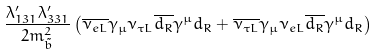Convert formula to latex. <formula><loc_0><loc_0><loc_500><loc_500>\frac { \lambda ^ { \prime } _ { 1 3 1 } \lambda ^ { \prime } _ { 3 3 1 } } { 2 m ^ { 2 } _ { \tilde { b } } } \left ( \overline { \nu _ { e L } } \gamma _ { \mu } \nu _ { \tau L } \overline { d _ { R } } \gamma ^ { \mu } d _ { R } + \overline { \nu _ { \tau L } } \gamma _ { \mu } \nu _ { e L } \overline { d _ { R } } \gamma ^ { \mu } d _ { R } \right )</formula> 